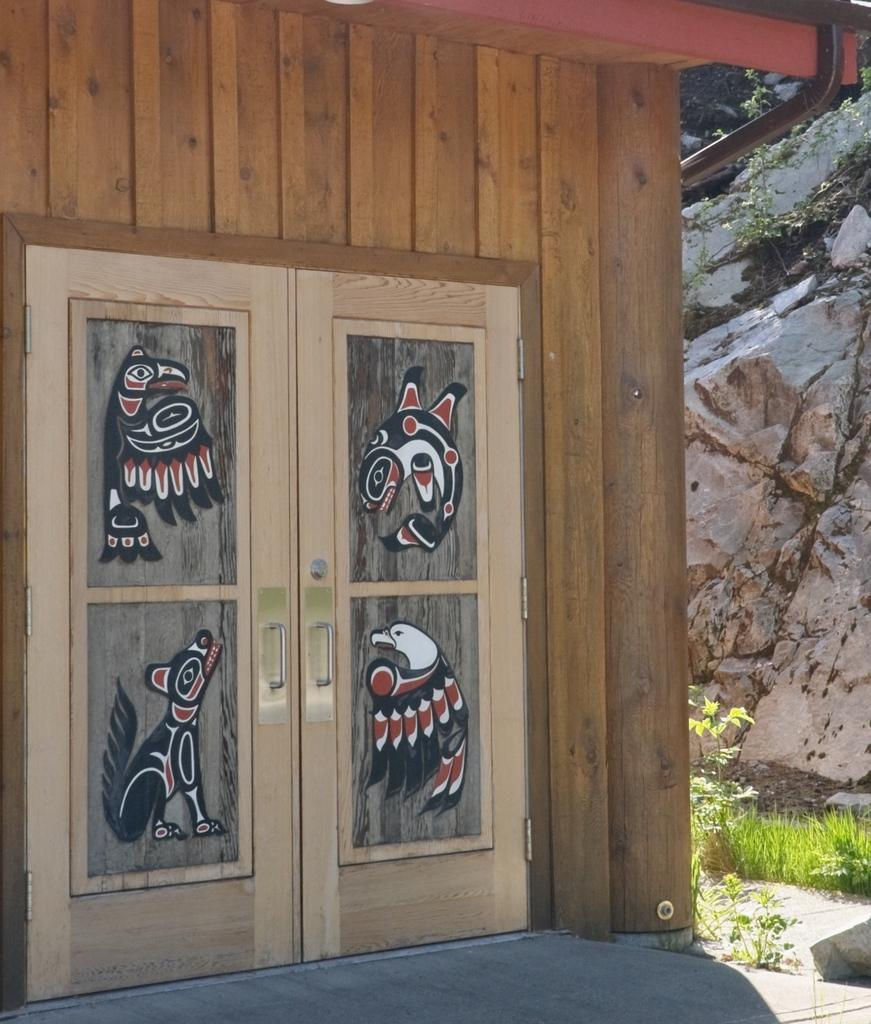What is the main architectural feature in the image? There is a door in the image. Can you describe the door in the image? The door has designs on it. What material is used for the wall in the image? The wall is made of wood. What can be seen on the right side of the image? There is a hill visible on the right side of the image. What type of vegetation is present in the image? There are plants on the ground in the image. Can you tell me how many secretaries are sitting behind the door in the image? There are no secretaries present in the image; it only features a door with designs, a wooden wall, a hill, and plants on the ground. 